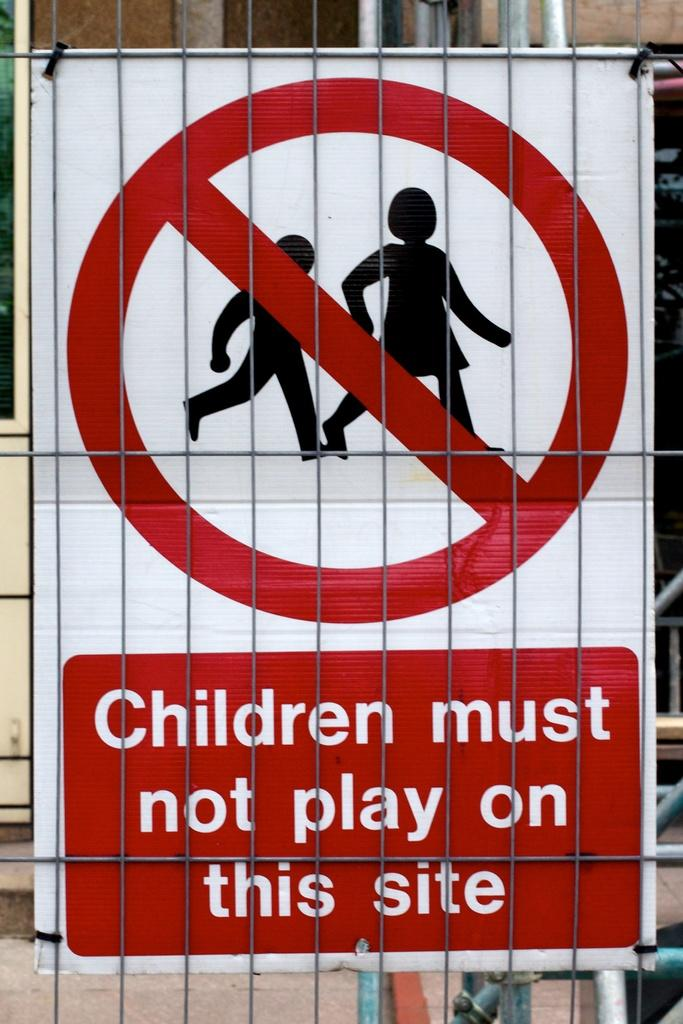<image>
Render a clear and concise summary of the photo. A sign is posted that warns children must not play on this site. 